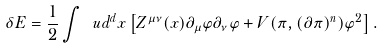Convert formula to latex. <formula><loc_0><loc_0><loc_500><loc_500>\delta E = \frac { 1 } { 2 } \int \ u d ^ { d } x \left [ Z ^ { \mu \nu } ( x ) \partial _ { \mu } \varphi \partial _ { \nu } \varphi + V ( \pi , ( \partial \pi ) ^ { n } ) \varphi ^ { 2 } \right ] .</formula> 